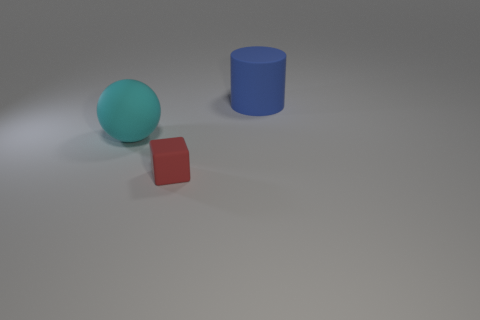Add 1 tiny red things. How many objects exist? 4 Subtract all blocks. How many objects are left? 2 Subtract all big blue metallic balls. Subtract all red rubber objects. How many objects are left? 2 Add 1 tiny rubber cubes. How many tiny rubber cubes are left? 2 Add 2 blue cylinders. How many blue cylinders exist? 3 Subtract 0 red balls. How many objects are left? 3 